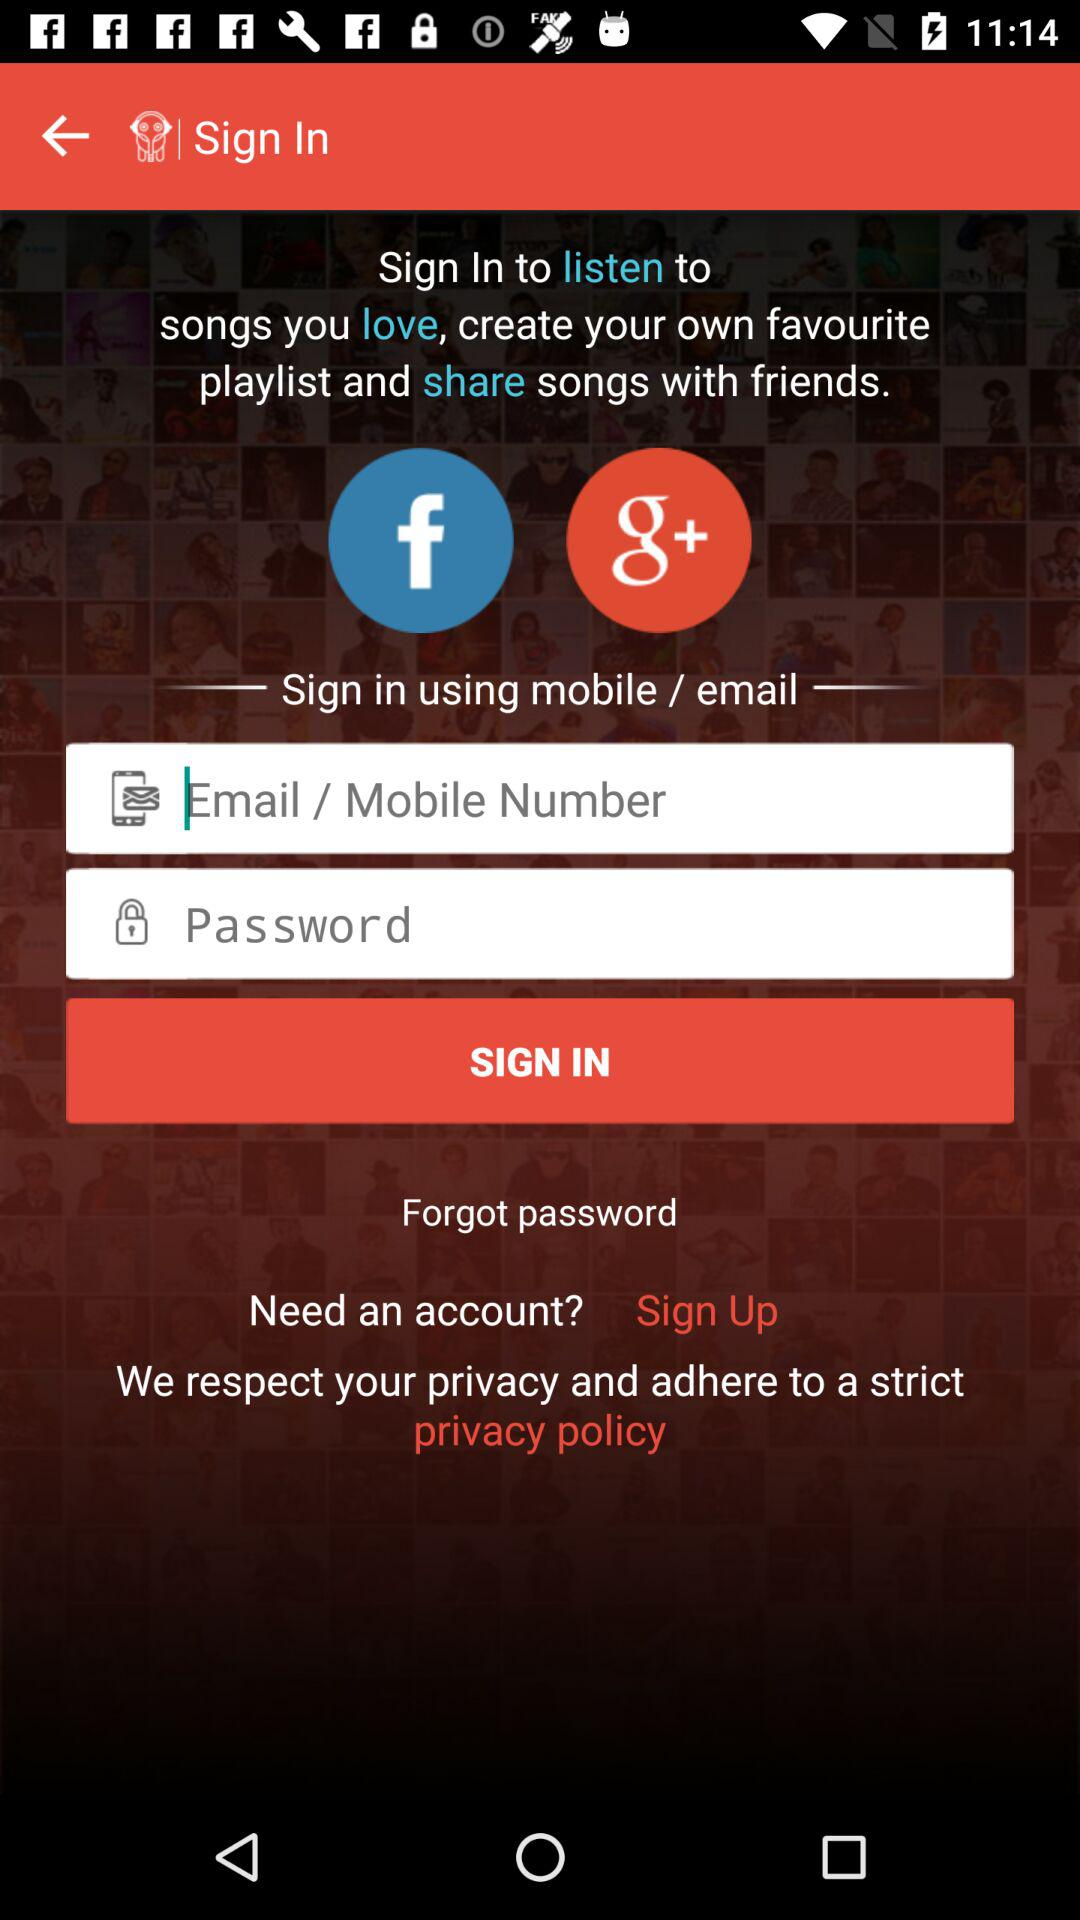How many characters long is the password?
When the provided information is insufficient, respond with <no answer>. <no answer> 